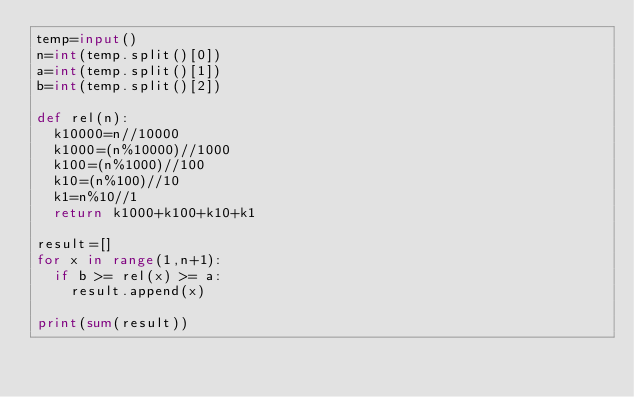<code> <loc_0><loc_0><loc_500><loc_500><_Python_>temp=input()
n=int(temp.split()[0])
a=int(temp.split()[1])
b=int(temp.split()[2])

def rel(n):
  k10000=n//10000
  k1000=(n%10000)//1000
  k100=(n%1000)//100
  k10=(n%100)//10
  k1=n%10//1
  return k1000+k100+k10+k1

result=[]
for x in range(1,n+1):
  if b >= rel(x) >= a:
    result.append(x)

print(sum(result))</code> 